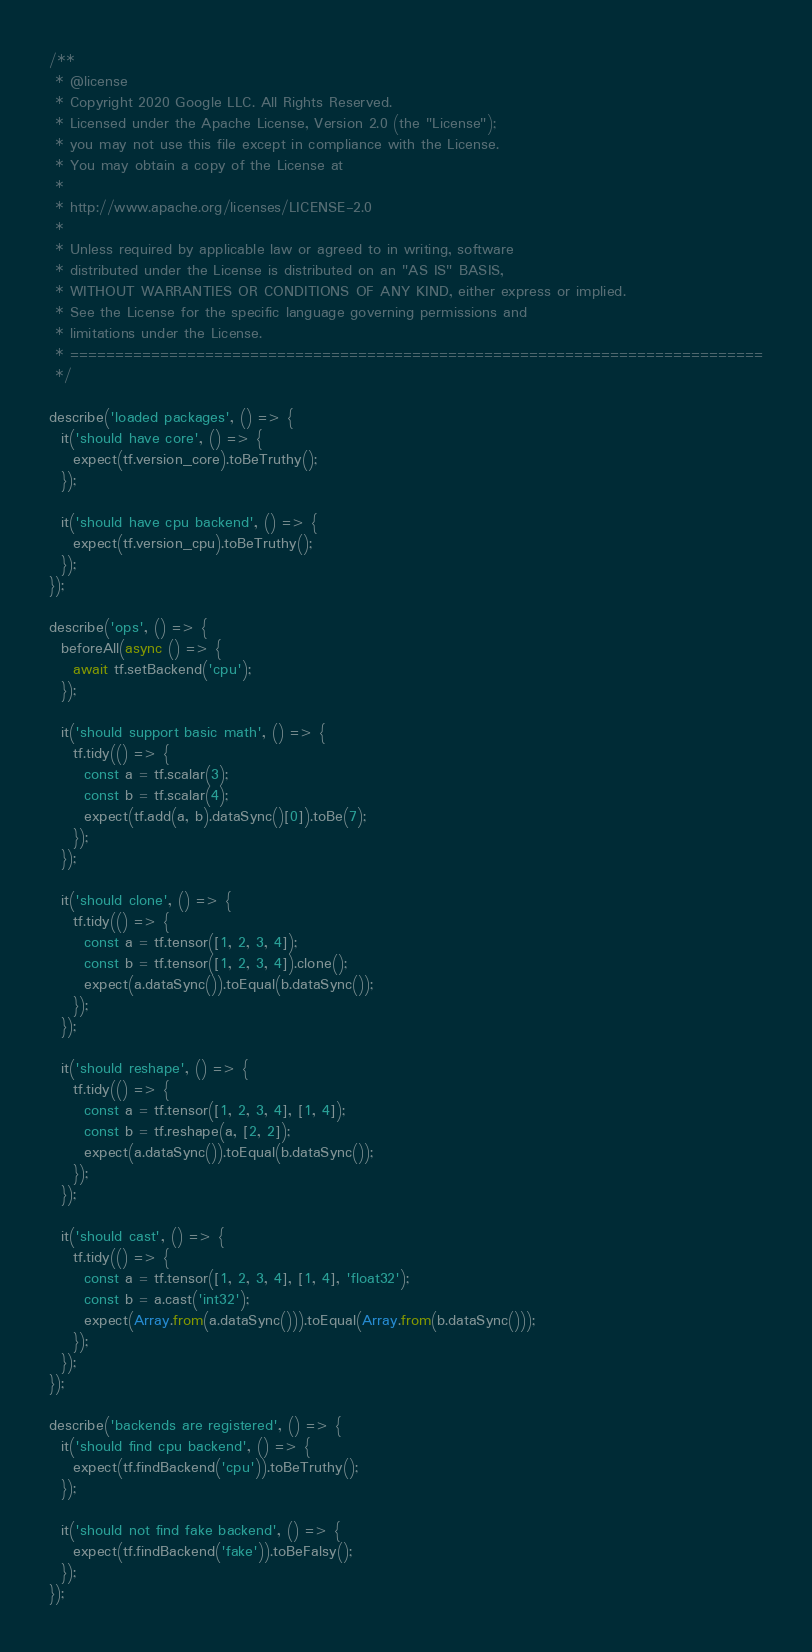Convert code to text. <code><loc_0><loc_0><loc_500><loc_500><_JavaScript_>/**
 * @license
 * Copyright 2020 Google LLC. All Rights Reserved.
 * Licensed under the Apache License, Version 2.0 (the "License");
 * you may not use this file except in compliance with the License.
 * You may obtain a copy of the License at
 *
 * http://www.apache.org/licenses/LICENSE-2.0
 *
 * Unless required by applicable law or agreed to in writing, software
 * distributed under the License is distributed on an "AS IS" BASIS,
 * WITHOUT WARRANTIES OR CONDITIONS OF ANY KIND, either express or implied.
 * See the License for the specific language governing permissions and
 * limitations under the License.
 * =============================================================================
 */

describe('loaded packages', () => {
  it('should have core', () => {
    expect(tf.version_core).toBeTruthy();
  });

  it('should have cpu backend', () => {
    expect(tf.version_cpu).toBeTruthy();
  });
});

describe('ops', () => {
  beforeAll(async () => {
    await tf.setBackend('cpu');
  });

  it('should support basic math', () => {
    tf.tidy(() => {
      const a = tf.scalar(3);
      const b = tf.scalar(4);
      expect(tf.add(a, b).dataSync()[0]).toBe(7);
    });
  });

  it('should clone', () => {
    tf.tidy(() => {
      const a = tf.tensor([1, 2, 3, 4]);
      const b = tf.tensor([1, 2, 3, 4]).clone();
      expect(a.dataSync()).toEqual(b.dataSync());
    });
  });

  it('should reshape', () => {
    tf.tidy(() => {
      const a = tf.tensor([1, 2, 3, 4], [1, 4]);
      const b = tf.reshape(a, [2, 2]);
      expect(a.dataSync()).toEqual(b.dataSync());
    });
  });

  it('should cast', () => {
    tf.tidy(() => {
      const a = tf.tensor([1, 2, 3, 4], [1, 4], 'float32');
      const b = a.cast('int32');
      expect(Array.from(a.dataSync())).toEqual(Array.from(b.dataSync()));
    });
  });
});

describe('backends are registered', () => {
  it('should find cpu backend', () => {
    expect(tf.findBackend('cpu')).toBeTruthy();
  });

  it('should not find fake backend', () => {
    expect(tf.findBackend('fake')).toBeFalsy();
  });
});
</code> 